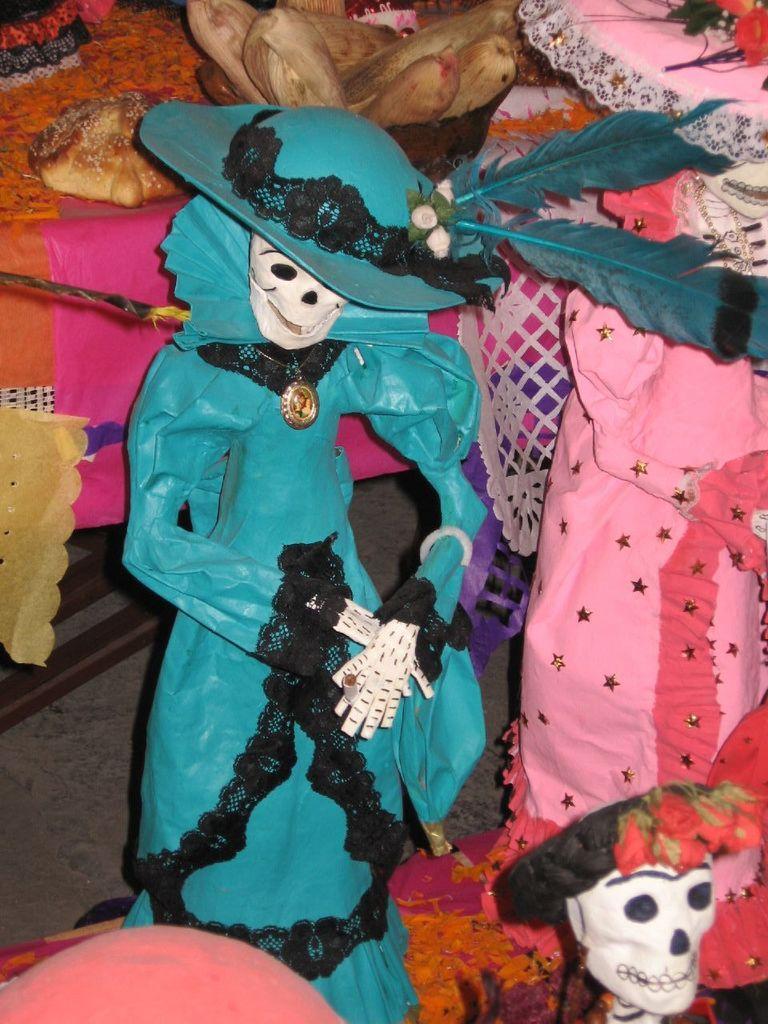Can you describe this image briefly? In this image, we can see dolls and in the background, there are some food items and we can see flowers and some clothes. At the bottom, there is a floor. 